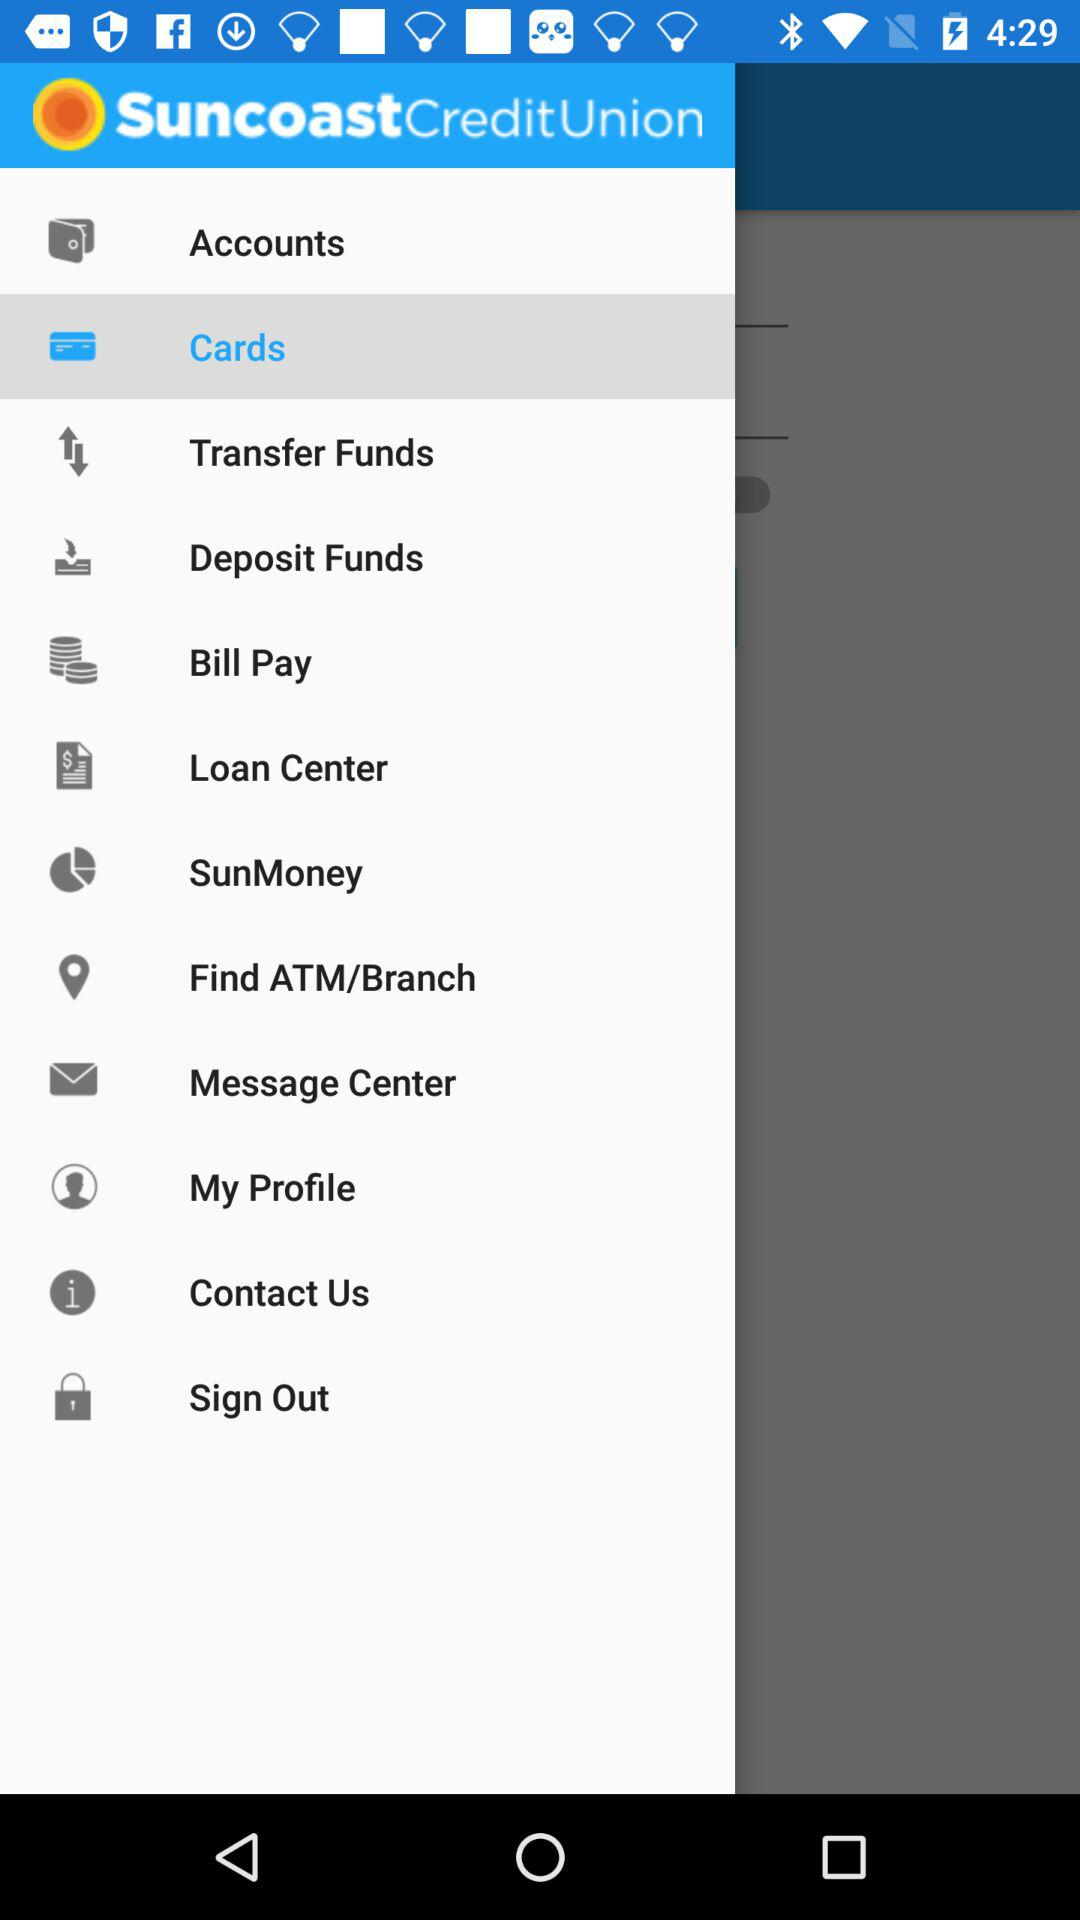Which item is selected? The selected item is "Cards". 